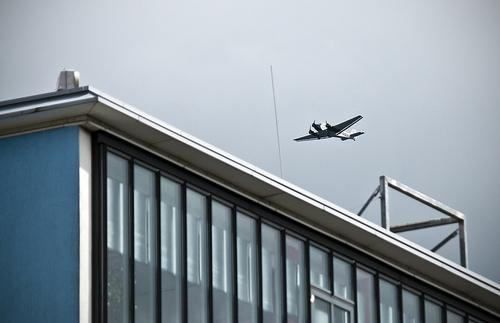Question: what is the square on top of the building made of?
Choices:
A. Brick.
B. Wood.
C. Glass.
D. Metal.
Answer with the letter. Answer: D Question: who operates the mode of transportation shown?
Choices:
A. Conductor.
B. Captain.
C. Pilot.
D. Bus driver.
Answer with the letter. Answer: C Question: where is the plane?
Choices:
A. On the tarmac.
B. In a garage.
C. In the water.
D. In the air.
Answer with the letter. Answer: D Question: what structure is below the airplane?
Choices:
A. A sculpture.
B. A building.
C. Houses.
D. Store.
Answer with the letter. Answer: B 